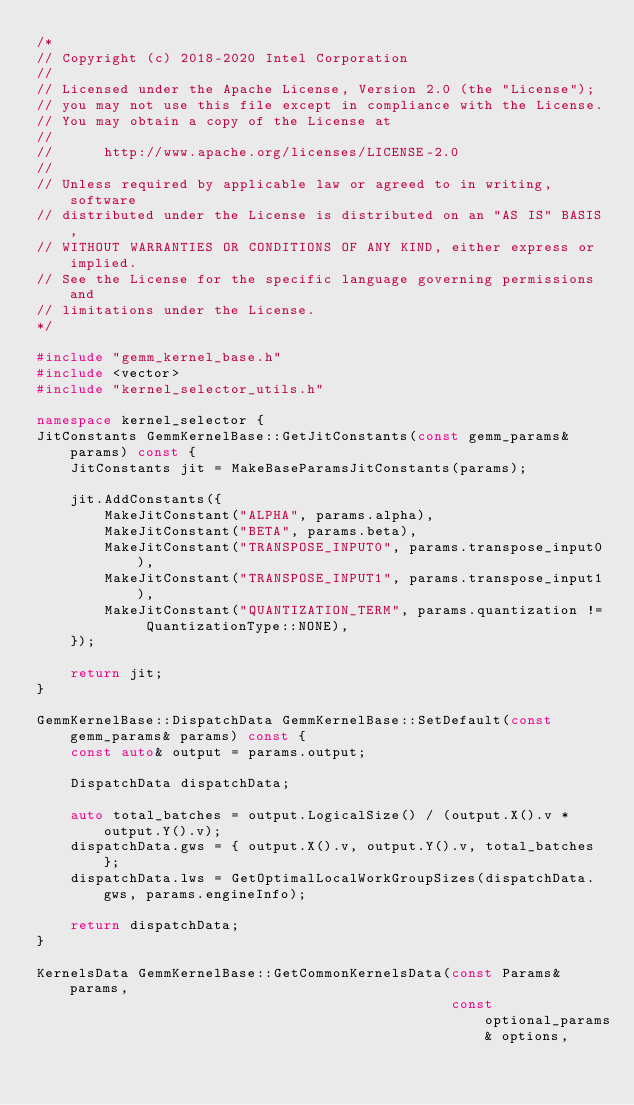<code> <loc_0><loc_0><loc_500><loc_500><_C++_>/*
// Copyright (c) 2018-2020 Intel Corporation
//
// Licensed under the Apache License, Version 2.0 (the "License");
// you may not use this file except in compliance with the License.
// You may obtain a copy of the License at
//
//      http://www.apache.org/licenses/LICENSE-2.0
//
// Unless required by applicable law or agreed to in writing, software
// distributed under the License is distributed on an "AS IS" BASIS,
// WITHOUT WARRANTIES OR CONDITIONS OF ANY KIND, either express or implied.
// See the License for the specific language governing permissions and
// limitations under the License.
*/

#include "gemm_kernel_base.h"
#include <vector>
#include "kernel_selector_utils.h"

namespace kernel_selector {
JitConstants GemmKernelBase::GetJitConstants(const gemm_params& params) const {
    JitConstants jit = MakeBaseParamsJitConstants(params);

    jit.AddConstants({
        MakeJitConstant("ALPHA", params.alpha),
        MakeJitConstant("BETA", params.beta),
        MakeJitConstant("TRANSPOSE_INPUT0", params.transpose_input0),
        MakeJitConstant("TRANSPOSE_INPUT1", params.transpose_input1),
        MakeJitConstant("QUANTIZATION_TERM", params.quantization != QuantizationType::NONE),
    });

    return jit;
}

GemmKernelBase::DispatchData GemmKernelBase::SetDefault(const gemm_params& params) const {
    const auto& output = params.output;

    DispatchData dispatchData;

    auto total_batches = output.LogicalSize() / (output.X().v * output.Y().v);
    dispatchData.gws = { output.X().v, output.Y().v, total_batches };
    dispatchData.lws = GetOptimalLocalWorkGroupSizes(dispatchData.gws, params.engineInfo);

    return dispatchData;
}

KernelsData GemmKernelBase::GetCommonKernelsData(const Params& params,
                                                 const optional_params& options,</code> 